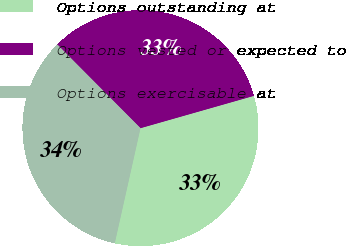Convert chart to OTSL. <chart><loc_0><loc_0><loc_500><loc_500><pie_chart><fcel>Options outstanding at<fcel>Options vested or expected to<fcel>Options exercisable at<nl><fcel>32.92%<fcel>33.03%<fcel>34.05%<nl></chart> 